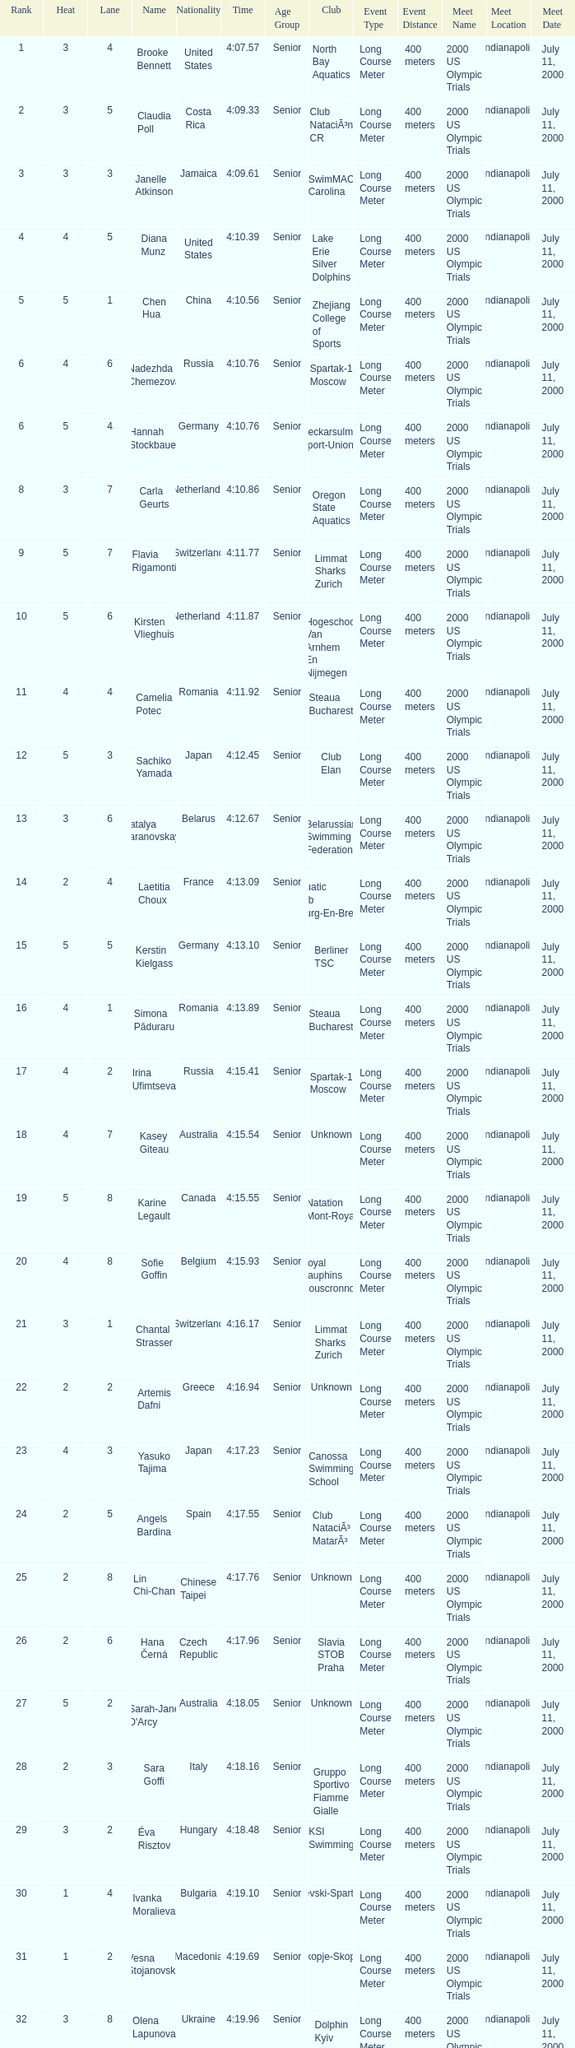Name the least lane for kasey giteau and rank less than 18 None. 